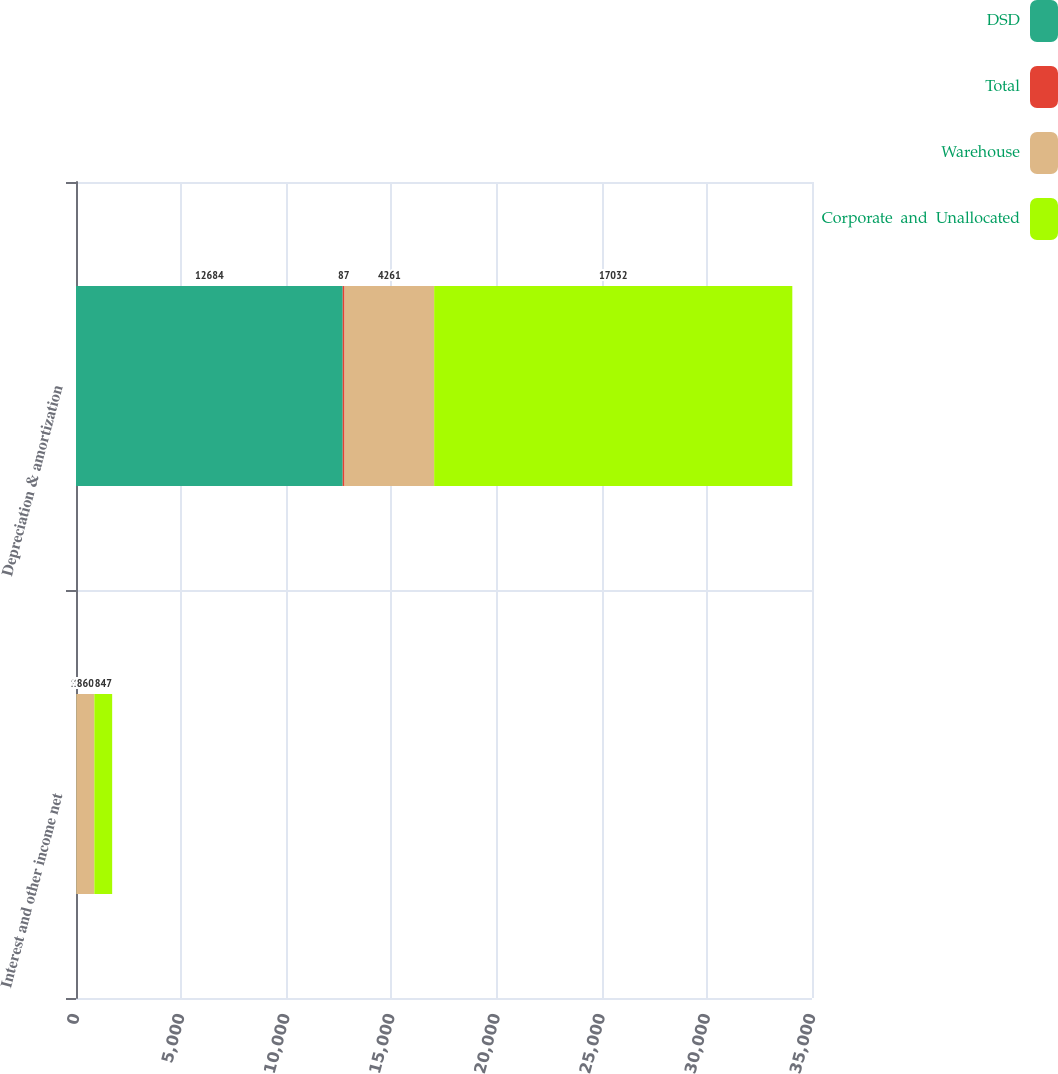<chart> <loc_0><loc_0><loc_500><loc_500><stacked_bar_chart><ecel><fcel>Interest and other income net<fcel>Depreciation & amortization<nl><fcel>DSD<fcel>12<fcel>12684<nl><fcel>Total<fcel>1<fcel>87<nl><fcel>Warehouse<fcel>860<fcel>4261<nl><fcel>Corporate  and  Unallocated<fcel>847<fcel>17032<nl></chart> 